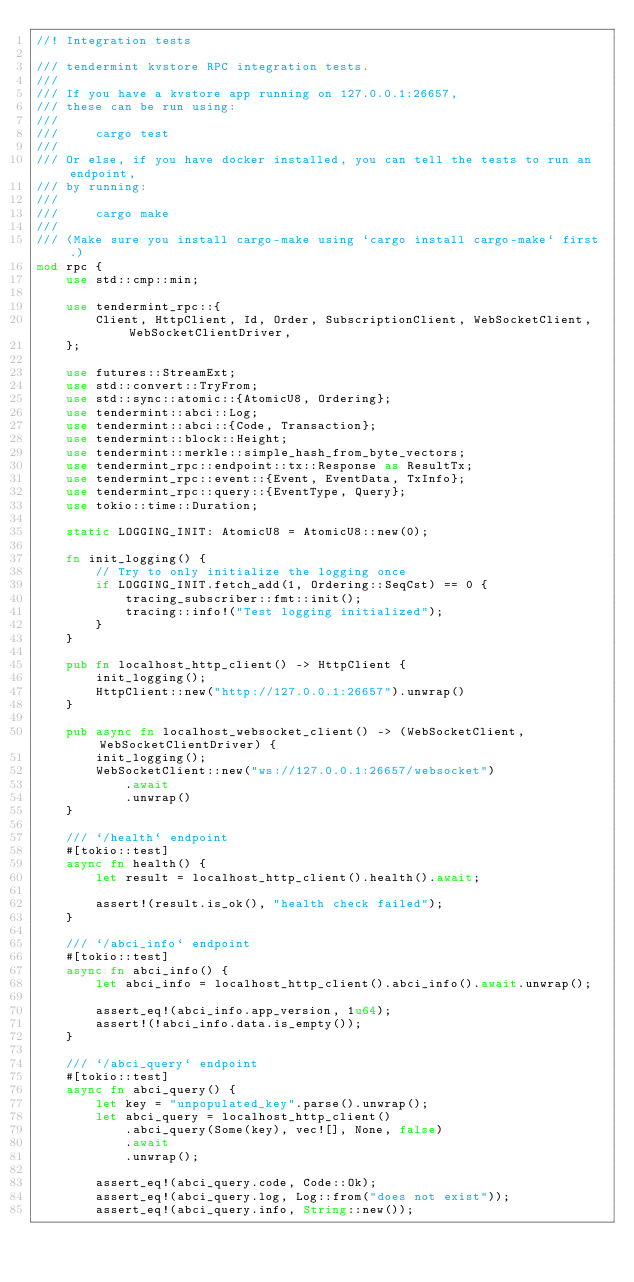<code> <loc_0><loc_0><loc_500><loc_500><_Rust_>//! Integration tests

/// tendermint kvstore RPC integration tests.
///
/// If you have a kvstore app running on 127.0.0.1:26657,
/// these can be run using:
///
///     cargo test
///
/// Or else, if you have docker installed, you can tell the tests to run an endpoint,
/// by running:
///
///     cargo make
///
/// (Make sure you install cargo-make using `cargo install cargo-make` first.)
mod rpc {
    use std::cmp::min;

    use tendermint_rpc::{
        Client, HttpClient, Id, Order, SubscriptionClient, WebSocketClient, WebSocketClientDriver,
    };

    use futures::StreamExt;
    use std::convert::TryFrom;
    use std::sync::atomic::{AtomicU8, Ordering};
    use tendermint::abci::Log;
    use tendermint::abci::{Code, Transaction};
    use tendermint::block::Height;
    use tendermint::merkle::simple_hash_from_byte_vectors;
    use tendermint_rpc::endpoint::tx::Response as ResultTx;
    use tendermint_rpc::event::{Event, EventData, TxInfo};
    use tendermint_rpc::query::{EventType, Query};
    use tokio::time::Duration;

    static LOGGING_INIT: AtomicU8 = AtomicU8::new(0);

    fn init_logging() {
        // Try to only initialize the logging once
        if LOGGING_INIT.fetch_add(1, Ordering::SeqCst) == 0 {
            tracing_subscriber::fmt::init();
            tracing::info!("Test logging initialized");
        }
    }

    pub fn localhost_http_client() -> HttpClient {
        init_logging();
        HttpClient::new("http://127.0.0.1:26657").unwrap()
    }

    pub async fn localhost_websocket_client() -> (WebSocketClient, WebSocketClientDriver) {
        init_logging();
        WebSocketClient::new("ws://127.0.0.1:26657/websocket")
            .await
            .unwrap()
    }

    /// `/health` endpoint
    #[tokio::test]
    async fn health() {
        let result = localhost_http_client().health().await;

        assert!(result.is_ok(), "health check failed");
    }

    /// `/abci_info` endpoint
    #[tokio::test]
    async fn abci_info() {
        let abci_info = localhost_http_client().abci_info().await.unwrap();

        assert_eq!(abci_info.app_version, 1u64);
        assert!(!abci_info.data.is_empty());
    }

    /// `/abci_query` endpoint
    #[tokio::test]
    async fn abci_query() {
        let key = "unpopulated_key".parse().unwrap();
        let abci_query = localhost_http_client()
            .abci_query(Some(key), vec![], None, false)
            .await
            .unwrap();

        assert_eq!(abci_query.code, Code::Ok);
        assert_eq!(abci_query.log, Log::from("does not exist"));
        assert_eq!(abci_query.info, String::new());</code> 